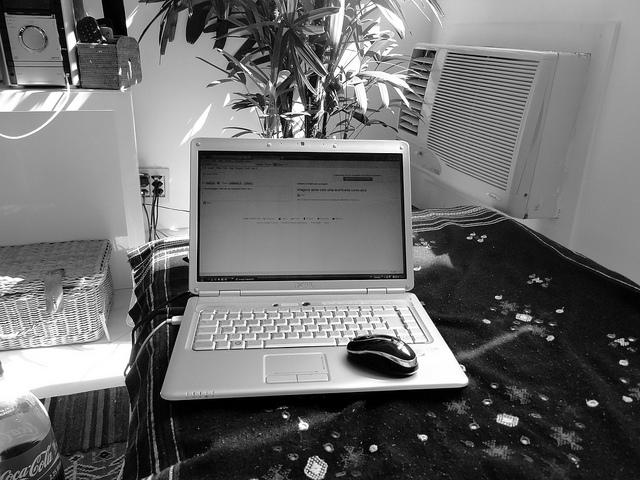Why would someone sit at this area?

Choices:
A) wash
B) work
C) clean
D) eat work 